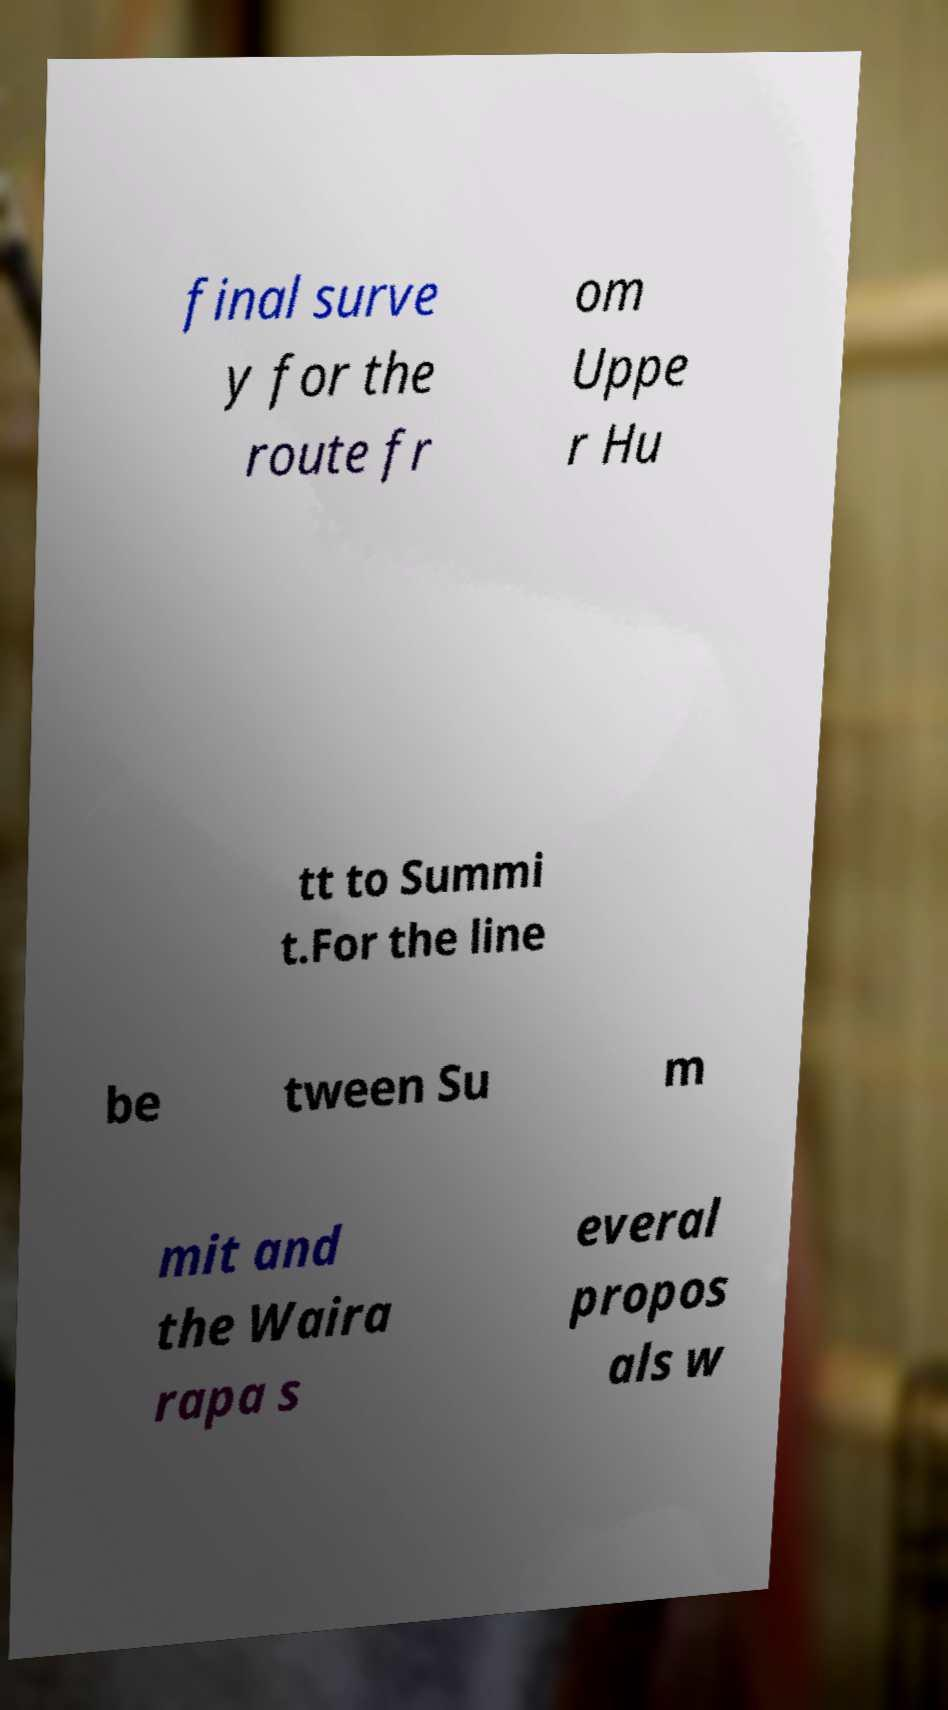Could you assist in decoding the text presented in this image and type it out clearly? final surve y for the route fr om Uppe r Hu tt to Summi t.For the line be tween Su m mit and the Waira rapa s everal propos als w 